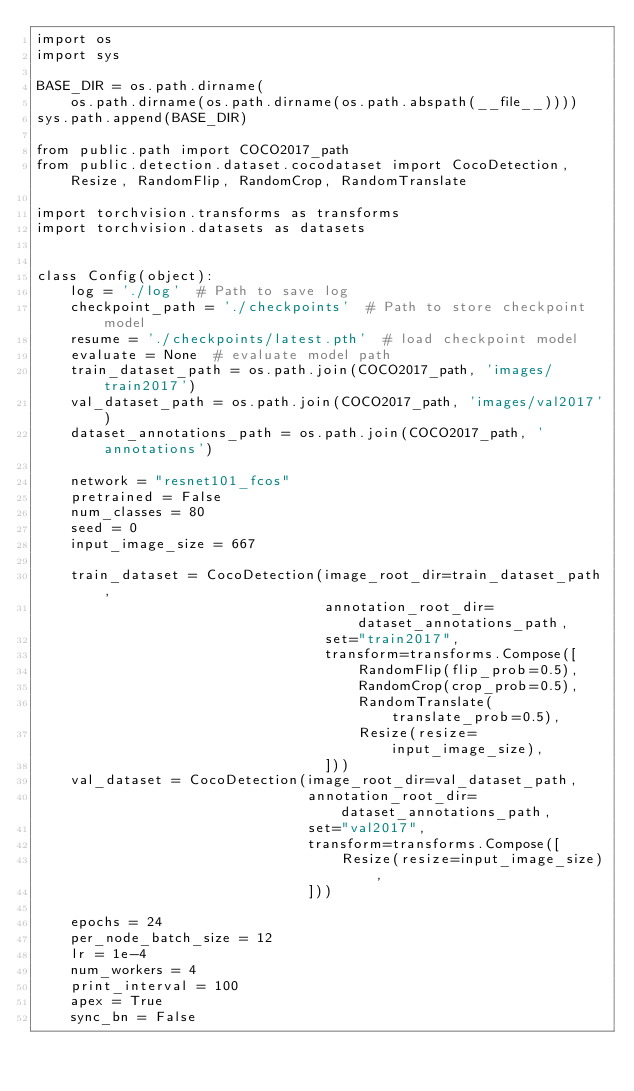Convert code to text. <code><loc_0><loc_0><loc_500><loc_500><_Python_>import os
import sys

BASE_DIR = os.path.dirname(
    os.path.dirname(os.path.dirname(os.path.abspath(__file__))))
sys.path.append(BASE_DIR)

from public.path import COCO2017_path
from public.detection.dataset.cocodataset import CocoDetection, Resize, RandomFlip, RandomCrop, RandomTranslate

import torchvision.transforms as transforms
import torchvision.datasets as datasets


class Config(object):
    log = './log'  # Path to save log
    checkpoint_path = './checkpoints'  # Path to store checkpoint model
    resume = './checkpoints/latest.pth'  # load checkpoint model
    evaluate = None  # evaluate model path
    train_dataset_path = os.path.join(COCO2017_path, 'images/train2017')
    val_dataset_path = os.path.join(COCO2017_path, 'images/val2017')
    dataset_annotations_path = os.path.join(COCO2017_path, 'annotations')

    network = "resnet101_fcos"
    pretrained = False
    num_classes = 80
    seed = 0
    input_image_size = 667

    train_dataset = CocoDetection(image_root_dir=train_dataset_path,
                                  annotation_root_dir=dataset_annotations_path,
                                  set="train2017",
                                  transform=transforms.Compose([
                                      RandomFlip(flip_prob=0.5),
                                      RandomCrop(crop_prob=0.5),
                                      RandomTranslate(translate_prob=0.5),
                                      Resize(resize=input_image_size),
                                  ]))
    val_dataset = CocoDetection(image_root_dir=val_dataset_path,
                                annotation_root_dir=dataset_annotations_path,
                                set="val2017",
                                transform=transforms.Compose([
                                    Resize(resize=input_image_size),
                                ]))

    epochs = 24
    per_node_batch_size = 12
    lr = 1e-4
    num_workers = 4
    print_interval = 100
    apex = True
    sync_bn = False</code> 